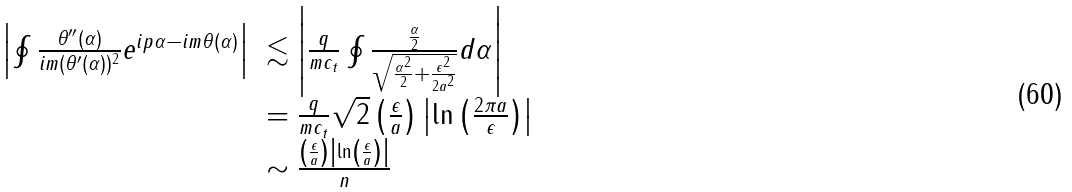Convert formula to latex. <formula><loc_0><loc_0><loc_500><loc_500>\begin{array} { l l } \left | \oint \frac { \theta ^ { \prime \prime } ( \alpha ) } { i m ( \theta ^ { \prime } ( \alpha ) ) ^ { 2 } } e ^ { i p \alpha - i m \theta ( \alpha ) } \right | & \lesssim \left | \frac { q } { m c _ { t } } \oint \frac { \frac { \alpha } { 2 } } { \sqrt { \frac { \alpha ^ { 2 } } { 2 } + \frac { \epsilon ^ { 2 } } { 2 a ^ { 2 } } } } d \alpha \right | \\ & = \frac { q } { m c _ { t } } \sqrt { 2 } \left ( \frac { \epsilon } { a } \right ) \left | \ln \left ( \frac { 2 \pi a } { \epsilon } \right ) \right | \\ & \sim \frac { \left ( \frac { \epsilon } { a } \right ) \left | \ln \left ( \frac { \epsilon } { a } \right ) \right | } { n } \end{array}</formula> 